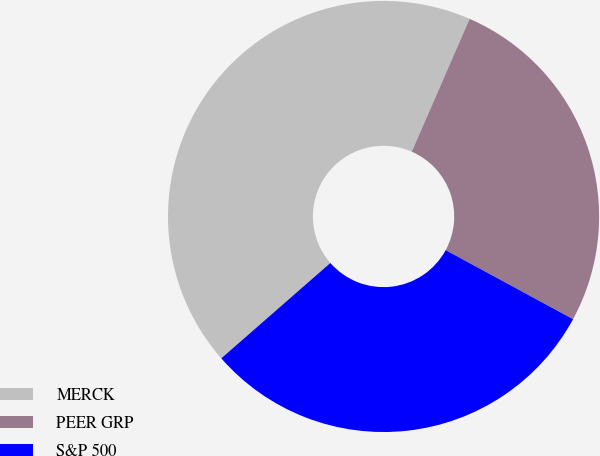<chart> <loc_0><loc_0><loc_500><loc_500><pie_chart><fcel>MERCK<fcel>PEER GRP<fcel>S&P 500<nl><fcel>42.97%<fcel>26.37%<fcel>30.66%<nl></chart> 